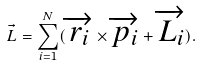<formula> <loc_0><loc_0><loc_500><loc_500>\vec { L } = \sum _ { i = 1 } ^ { N } ( \overrightarrow { r _ { i } } \times \overrightarrow { p _ { i } } + \overrightarrow { L _ { i } } ) .</formula> 